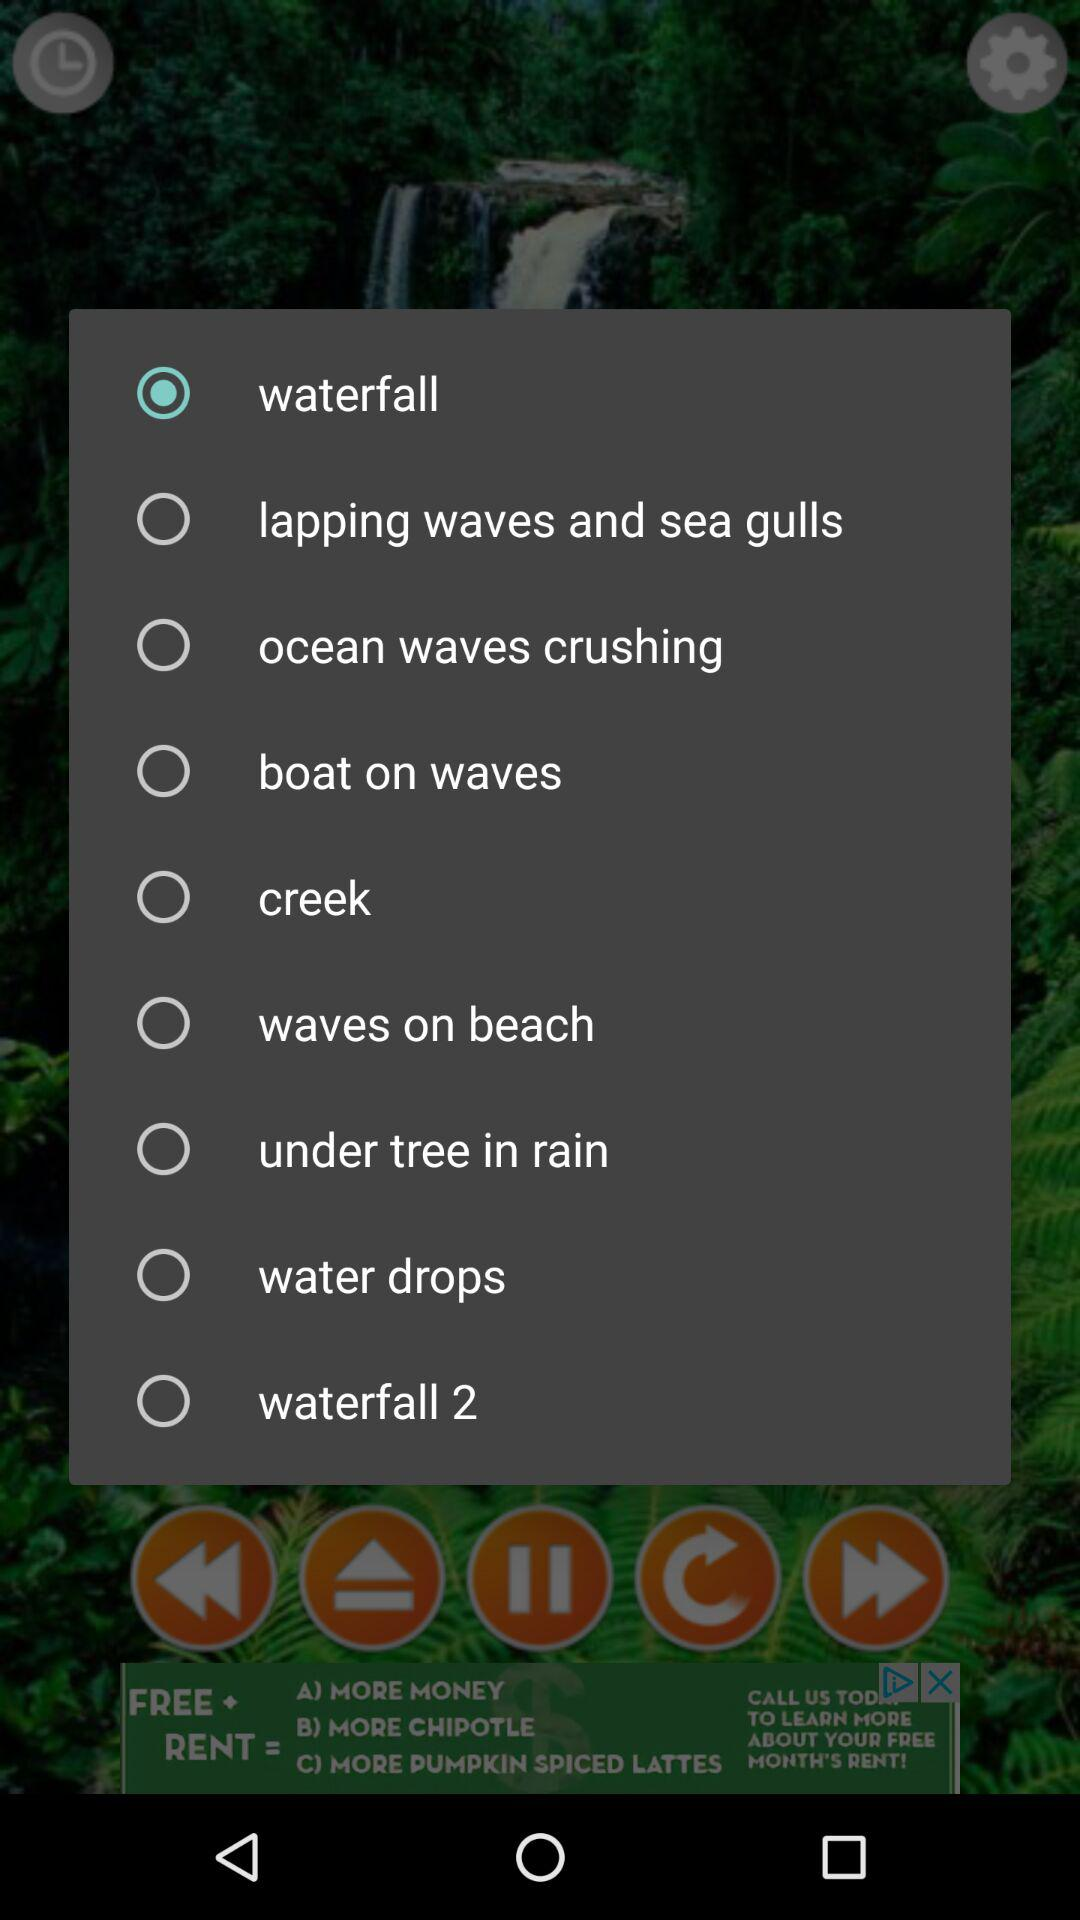Is "creek" selected or not? It is not selected. 